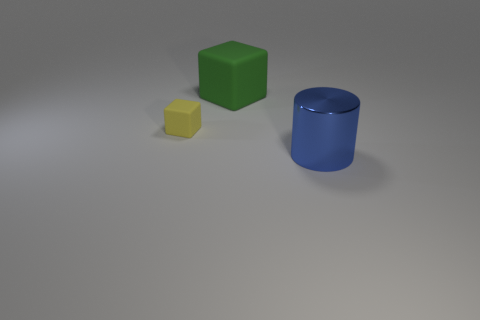Add 2 small yellow metallic balls. How many objects exist? 5 Subtract 1 cubes. How many cubes are left? 1 Add 2 big blue cylinders. How many big blue cylinders are left? 3 Add 3 green objects. How many green objects exist? 4 Subtract all yellow cubes. How many cubes are left? 1 Subtract 0 red blocks. How many objects are left? 3 Subtract all cylinders. How many objects are left? 2 Subtract all purple cubes. Subtract all yellow cylinders. How many cubes are left? 2 Subtract all blue spheres. How many green cubes are left? 1 Subtract all tiny cyan metal things. Subtract all big green matte cubes. How many objects are left? 2 